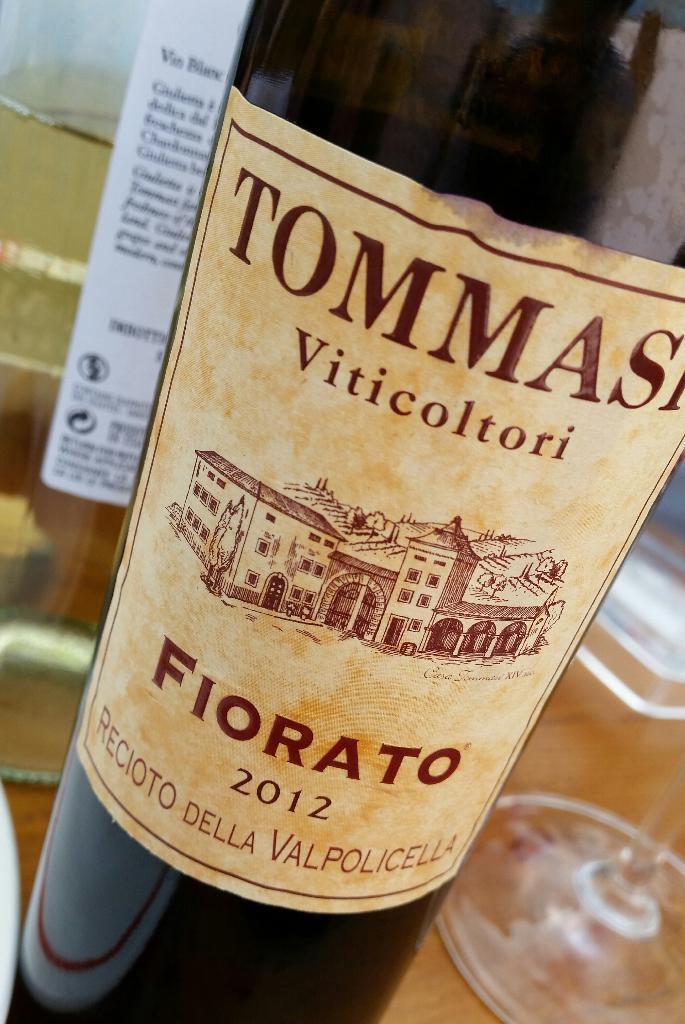<image>
Write a terse but informative summary of the picture. the word tommas that is on a wine bottle 